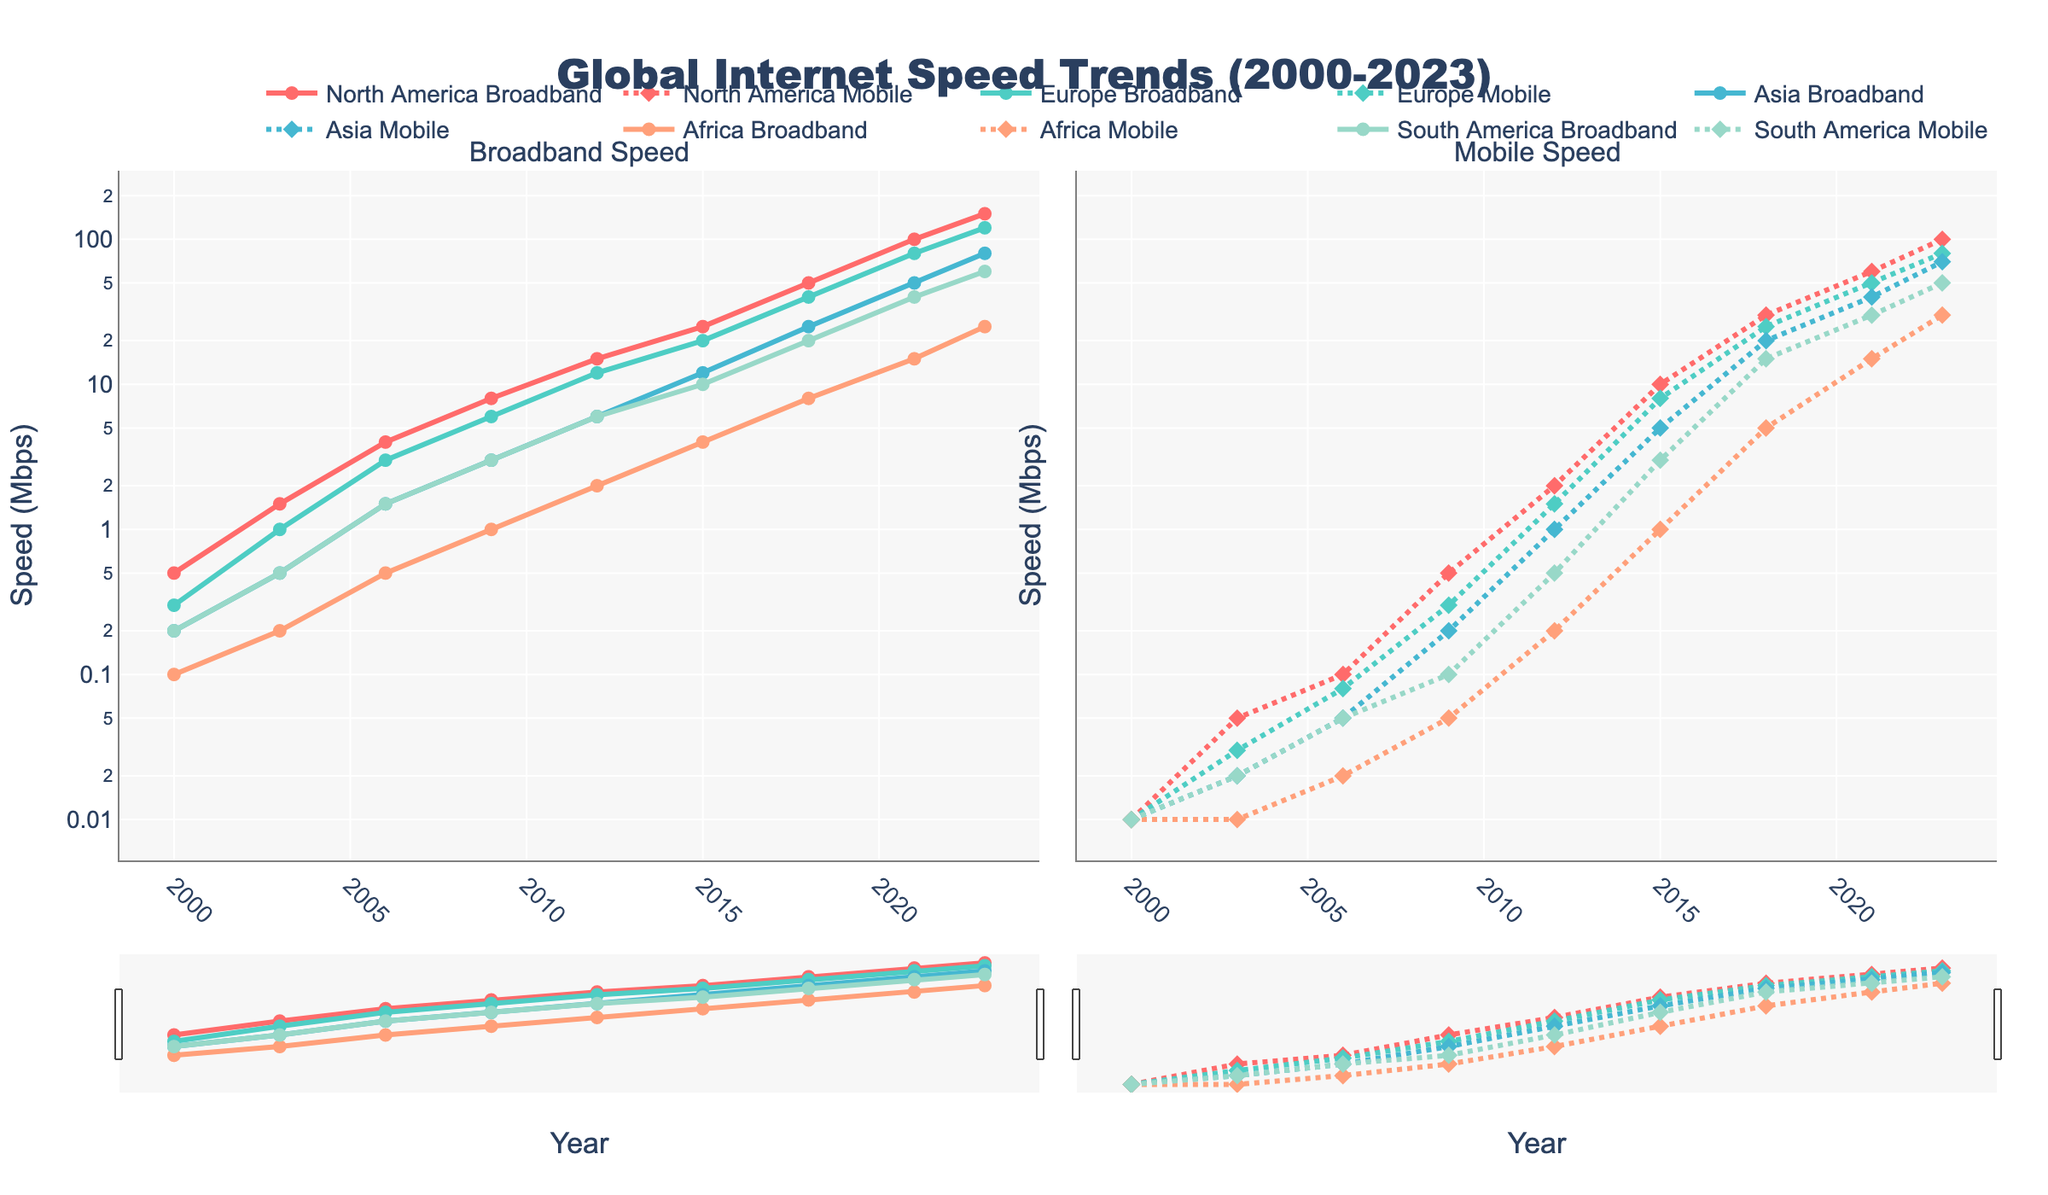What region had the highest broadband speed in 2023? To determine the highest broadband speed in 2023, check the values for all regions in that year. The data shows North America with 150 Mbps, Europe with 120 Mbps, Asia with 80 Mbps, Africa with 25 Mbps, and South America with 60 Mbps.
Answer: North America Which year saw the greatest increase in mobile speed for North America? Track the differences in mobile speed for North America between consecutive years. The changes are 0.01 (2000 to 2003), 0.05 (2003 to 2006), 0.4 (2006 to 2009), 1.5 (2009 to 2012), 8 (2012 to 2015), 20 (2015 to 2018), 30 (2018 to 2021), 40 (2021 to 2023). The greatest increase is from 2021 to 2023, where the speed increased by 40 Mbps.
Answer: 2021 to 2023 How does Africa's broadband speed in 2015 compare to Europe's broadband speed in 2003? Africa's broadband speed in 2015 is 4 Mbps, while Europe's broadband speed in 2003 is 1 Mbps. Comparing the two, Africa's broadband speed in 2015 is 3 Mbps higher than Europe's broadband speed in 2003.
Answer: Africa's speed is higher by 3 Mbps Which region shows the smallest difference between broadband and mobile speeds in 2023? Calculate the difference between broadband and mobile speeds for each region in 2023: North America (150 - 100 = 50), Europe (120 - 80 = 40), Asia (80 - 70 = 10), Africa (25 - 30 = -5), South America (60 - 50 = 10). Africa's difference is -5 Mbps, the closest among all regions.
Answer: Africa In what year does Asia's broadband speed first exceed 10 Mbps? Check the values for Asia's broadband speed in each year. The speeds are 0.2 (2000), 0.5 (2003), 1.5 (2006), 3.0 (2009), 6.0 (2012), 12.0 (2015). Asia's broadband speed first exceeds 10 Mbps in 2015.
Answer: 2015 By how much did Europe's broadband speed increase from 2000 to 2003? Subtract Europe's broadband speed in 2000 from its broadband speed in 2003. The speeds are 1.0 (2003) and 0.3 (2000), so the increase is 1.0 - 0.3 = 0.7 Mbps.
Answer: 0.7 Mbps What is the average mobile speed for South America over the entire period? Calculate the average by adding all South American mobile speeds and dividing by the number of data points: (0.01 + 0.02 + 0.05 + 0.1 + 0.5 + 3.0 + 15.0 + 30.0 + 50.0) / 9. Summing these speeds gives 98.68, so the average is 98.68 / 9 ≈ 10.96 Mbps.
Answer: ≈ 10.96 Mbps How does the growth rate of broadband speeds in Asia from 2006 to 2009 compare to that from 2018 to 2021? Calculate the growth rates for Asia's broadband speeds in both periods: From 2006 to 2009 (3.0 - 1.5 = 1.5 Mbps increase), from 2018 to 2021 (50.0 - 25.0 = 25.0 Mbps increase). Comparing these growth rates, 25.0 Mbps is significantly higher than 1.5 Mbps.
Answer: Growth was higher from 2018 to 2021 